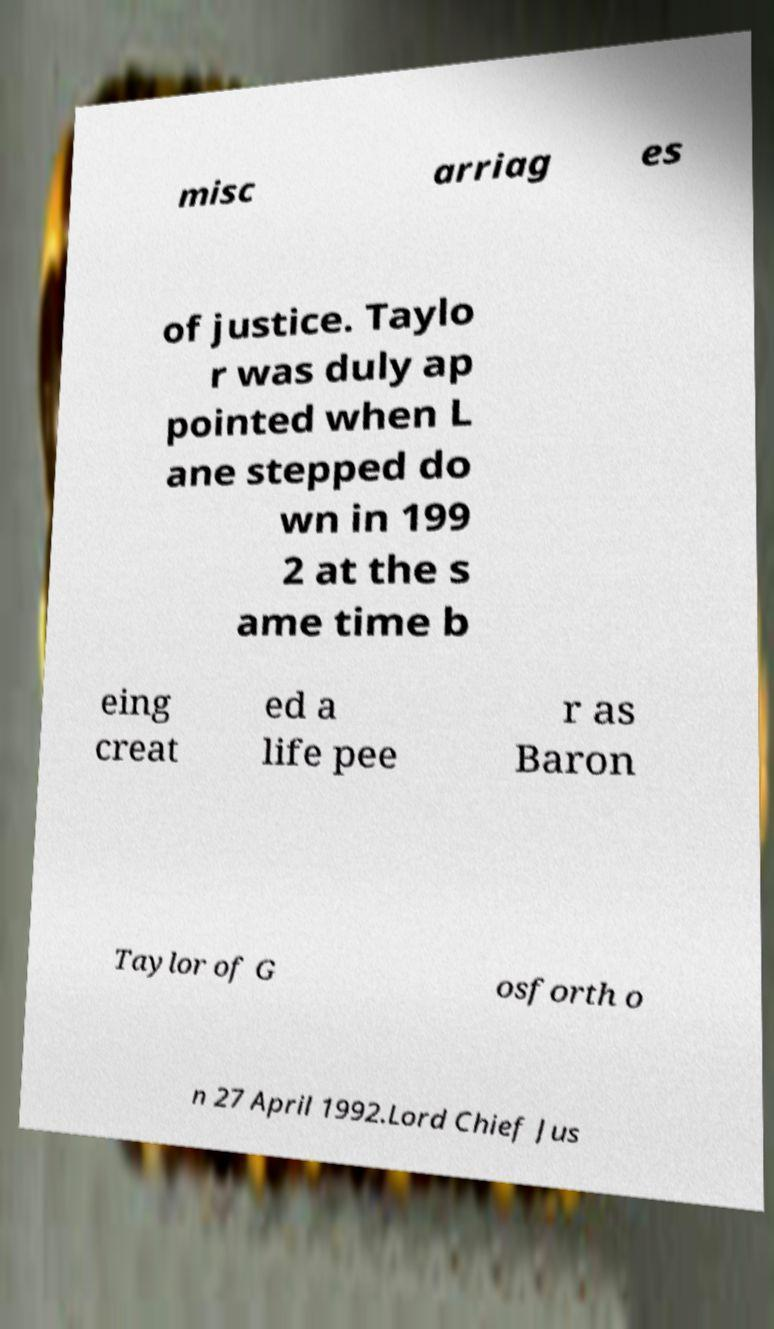What messages or text are displayed in this image? I need them in a readable, typed format. misc arriag es of justice. Taylo r was duly ap pointed when L ane stepped do wn in 199 2 at the s ame time b eing creat ed a life pee r as Baron Taylor of G osforth o n 27 April 1992.Lord Chief Jus 